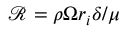<formula> <loc_0><loc_0><loc_500><loc_500>\mathcal { R } = \rho \Omega r _ { i } \delta / \mu</formula> 